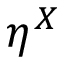<formula> <loc_0><loc_0><loc_500><loc_500>\eta ^ { X }</formula> 